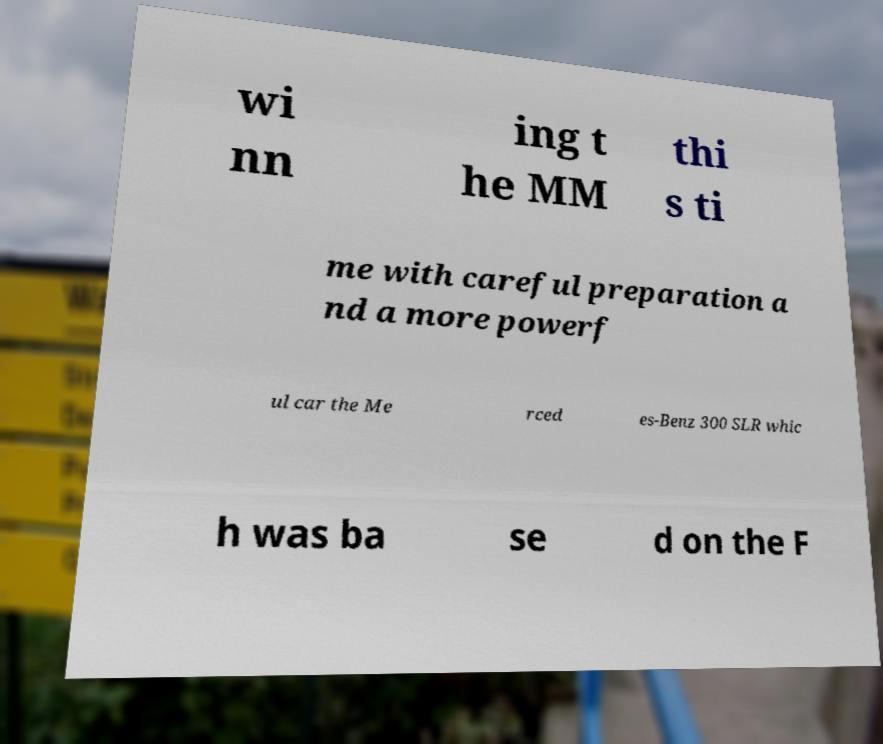What messages or text are displayed in this image? I need them in a readable, typed format. wi nn ing t he MM thi s ti me with careful preparation a nd a more powerf ul car the Me rced es-Benz 300 SLR whic h was ba se d on the F 